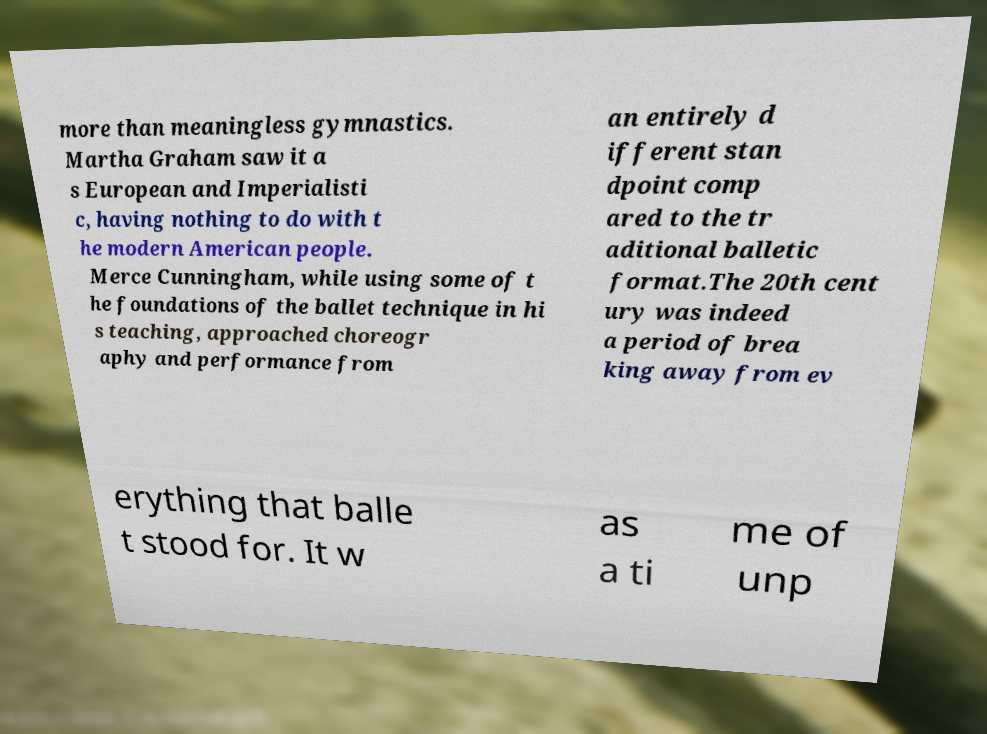Could you extract and type out the text from this image? more than meaningless gymnastics. Martha Graham saw it a s European and Imperialisti c, having nothing to do with t he modern American people. Merce Cunningham, while using some of t he foundations of the ballet technique in hi s teaching, approached choreogr aphy and performance from an entirely d ifferent stan dpoint comp ared to the tr aditional balletic format.The 20th cent ury was indeed a period of brea king away from ev erything that balle t stood for. It w as a ti me of unp 